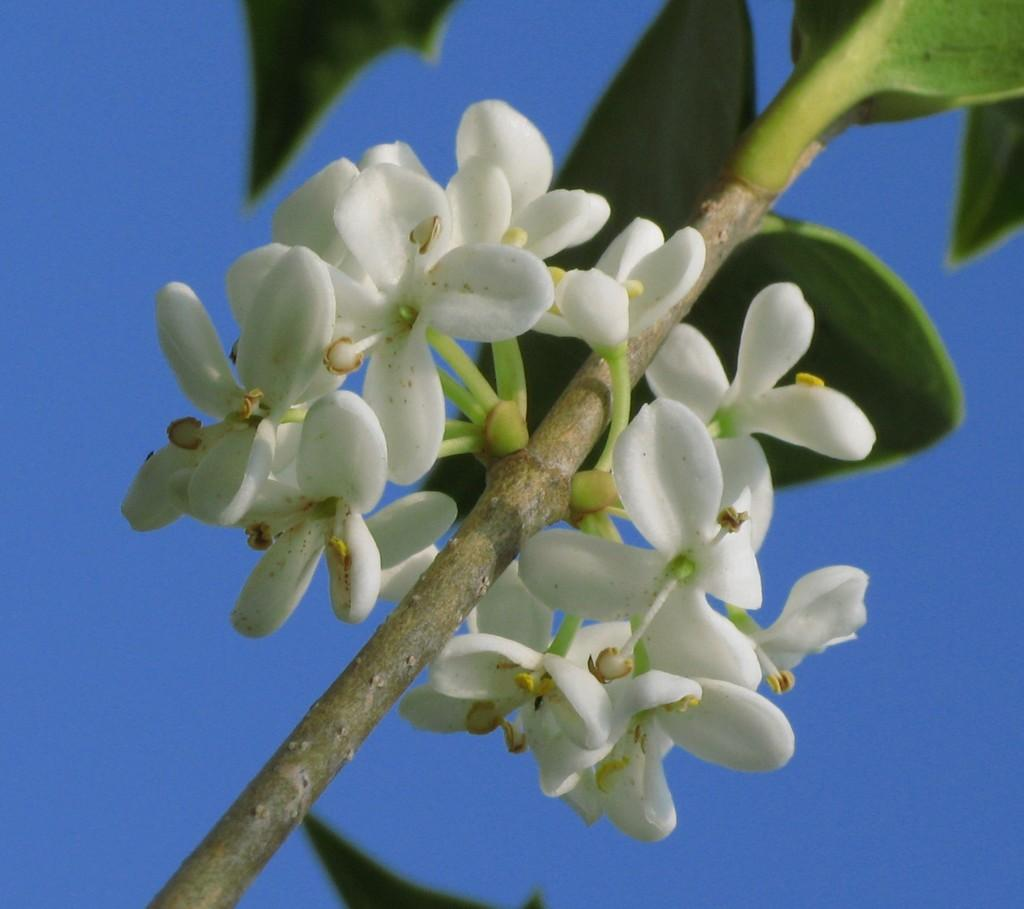What is the main subject in the center of the image? There is a plant in the center of the image. What can be seen on the plant? There are flowers on the plant. What color are the flowers? The flowers are white in color. What can be seen in the background of the image? There is a sky visible in the background of the image. Where is the pig located in the image? There is no pig present in the image. What type of screw can be seen holding the plant to the ground? There is no screw visible in the image; the plant is not attached to the ground. 